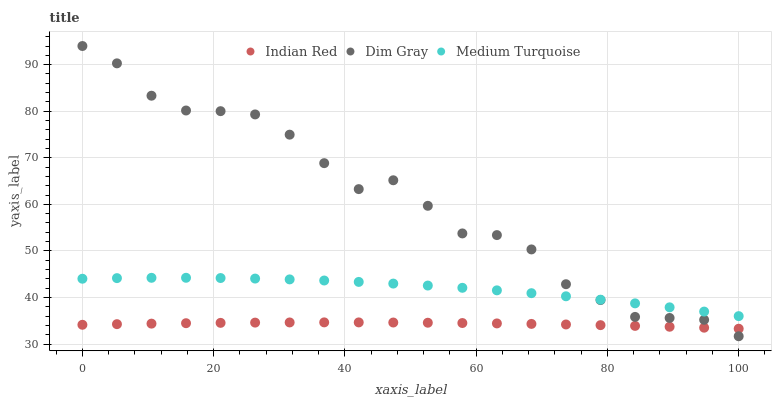Does Indian Red have the minimum area under the curve?
Answer yes or no. Yes. Does Dim Gray have the maximum area under the curve?
Answer yes or no. Yes. Does Medium Turquoise have the minimum area under the curve?
Answer yes or no. No. Does Medium Turquoise have the maximum area under the curve?
Answer yes or no. No. Is Indian Red the smoothest?
Answer yes or no. Yes. Is Dim Gray the roughest?
Answer yes or no. Yes. Is Medium Turquoise the smoothest?
Answer yes or no. No. Is Medium Turquoise the roughest?
Answer yes or no. No. Does Dim Gray have the lowest value?
Answer yes or no. Yes. Does Indian Red have the lowest value?
Answer yes or no. No. Does Dim Gray have the highest value?
Answer yes or no. Yes. Does Medium Turquoise have the highest value?
Answer yes or no. No. Is Indian Red less than Medium Turquoise?
Answer yes or no. Yes. Is Medium Turquoise greater than Indian Red?
Answer yes or no. Yes. Does Dim Gray intersect Medium Turquoise?
Answer yes or no. Yes. Is Dim Gray less than Medium Turquoise?
Answer yes or no. No. Is Dim Gray greater than Medium Turquoise?
Answer yes or no. No. Does Indian Red intersect Medium Turquoise?
Answer yes or no. No. 